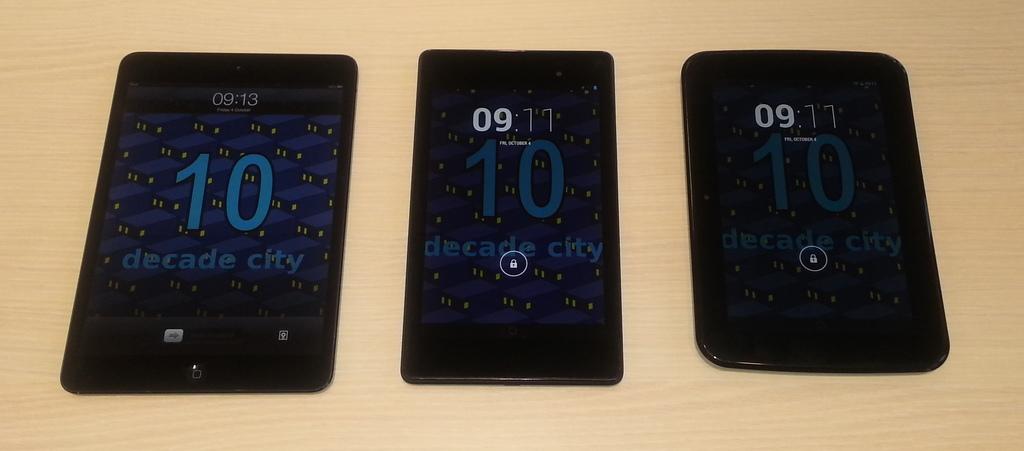What city is mentioned on the p hone screen?
Keep it short and to the point. Decade city. What time is on the phone to the left?
Ensure brevity in your answer.  9:13. 